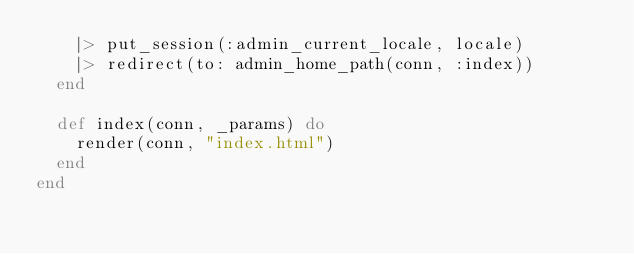Convert code to text. <code><loc_0><loc_0><loc_500><loc_500><_Elixir_>    |> put_session(:admin_current_locale, locale)
    |> redirect(to: admin_home_path(conn, :index))
  end

  def index(conn, _params) do
    render(conn, "index.html")
  end
end
</code> 